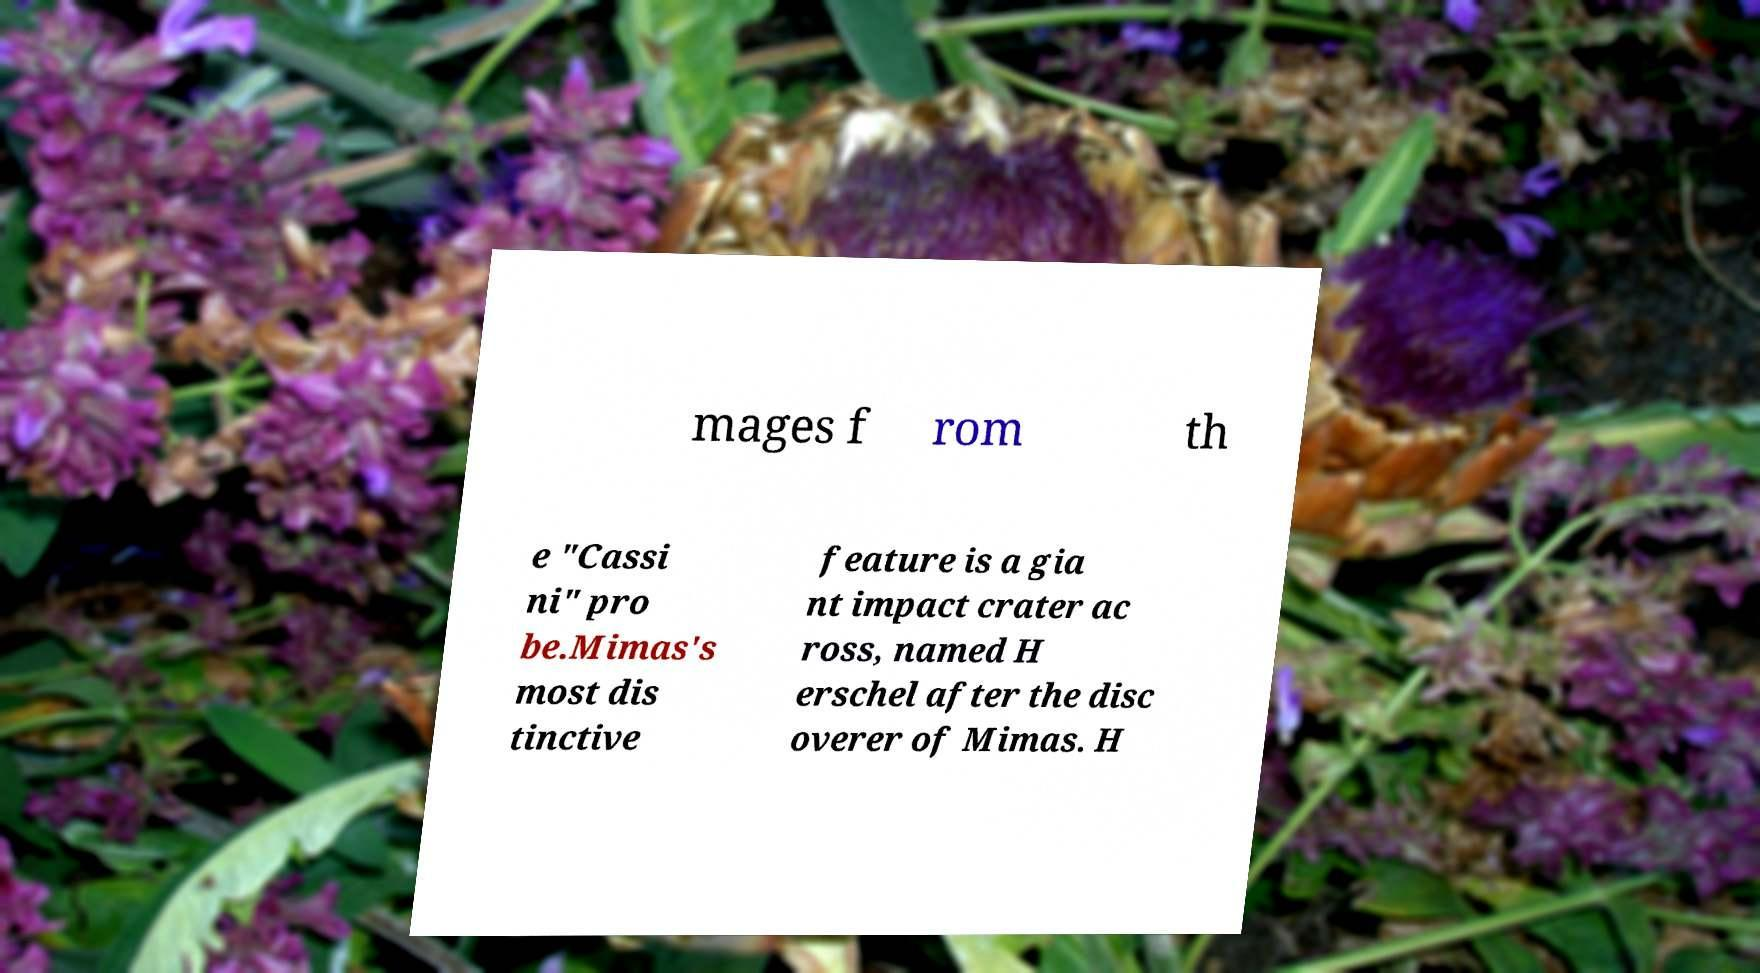Can you read and provide the text displayed in the image?This photo seems to have some interesting text. Can you extract and type it out for me? mages f rom th e "Cassi ni" pro be.Mimas's most dis tinctive feature is a gia nt impact crater ac ross, named H erschel after the disc overer of Mimas. H 